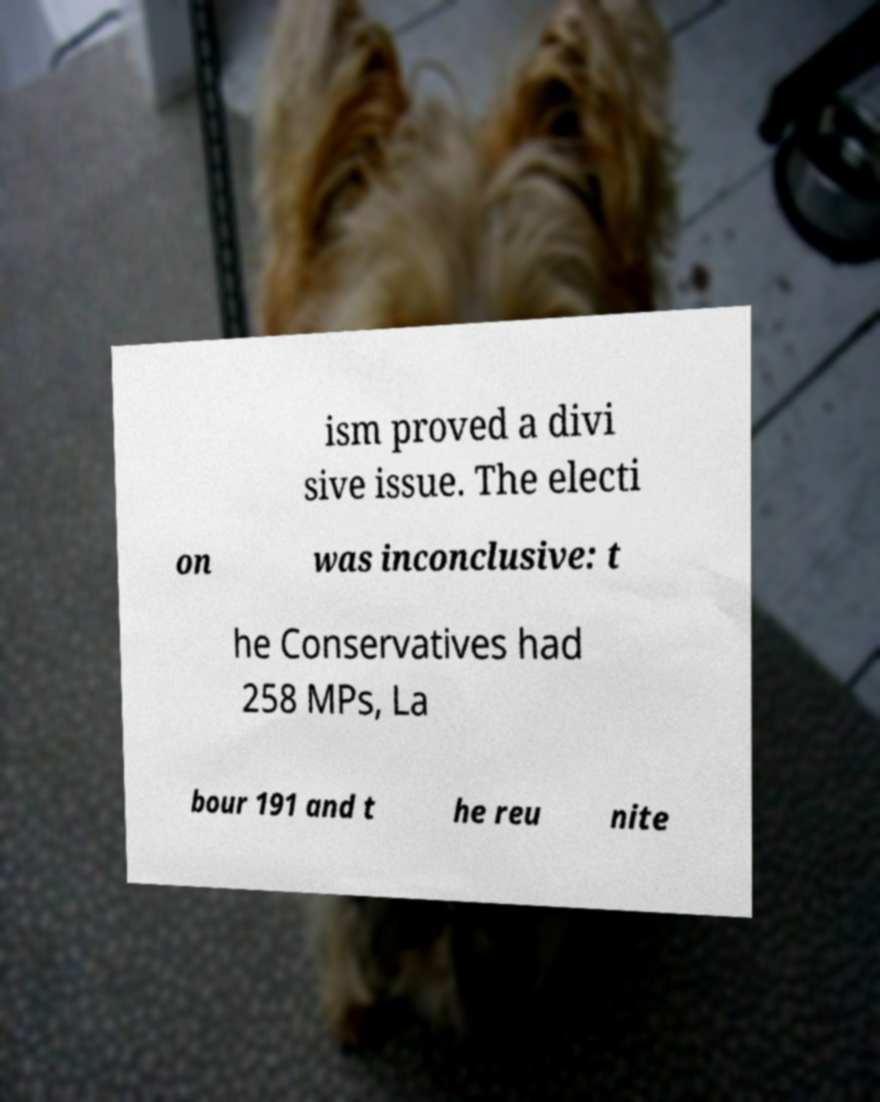There's text embedded in this image that I need extracted. Can you transcribe it verbatim? ism proved a divi sive issue. The electi on was inconclusive: t he Conservatives had 258 MPs, La bour 191 and t he reu nite 